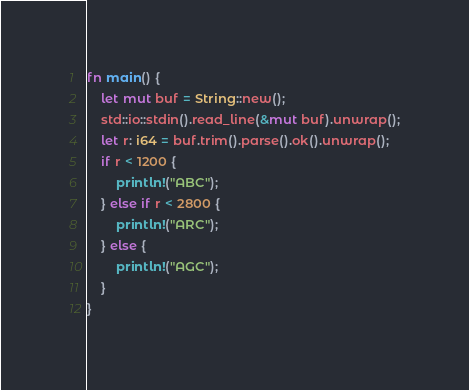<code> <loc_0><loc_0><loc_500><loc_500><_Rust_>fn main() {
    let mut buf = String::new();
    std::io::stdin().read_line(&mut buf).unwrap();
    let r: i64 = buf.trim().parse().ok().unwrap();
    if r < 1200 {
        println!("ABC");
    } else if r < 2800 {
        println!("ARC");
    } else {
        println!("AGC");
    }
}
</code> 